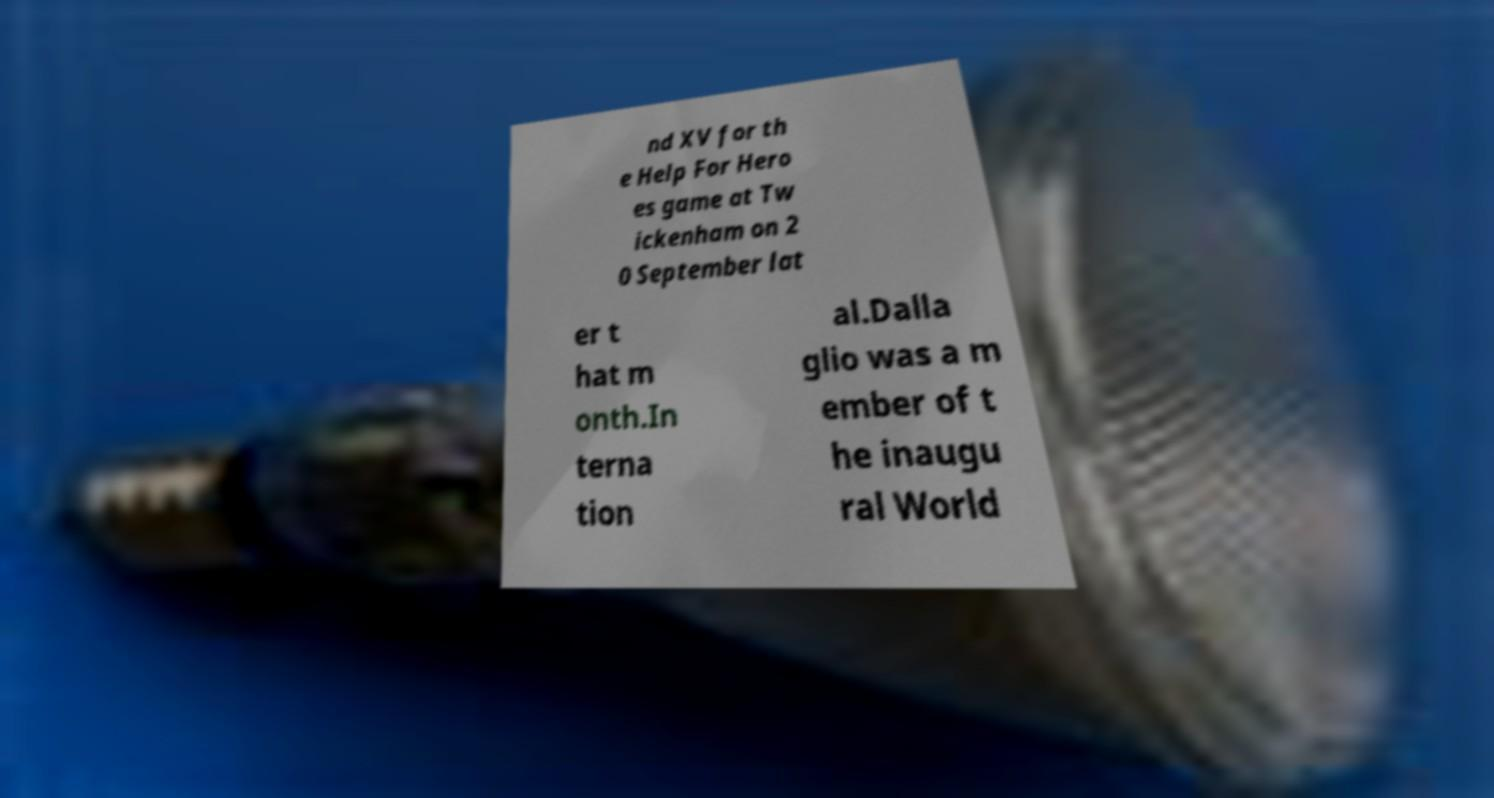Could you assist in decoding the text presented in this image and type it out clearly? nd XV for th e Help For Hero es game at Tw ickenham on 2 0 September lat er t hat m onth.In terna tion al.Dalla glio was a m ember of t he inaugu ral World 